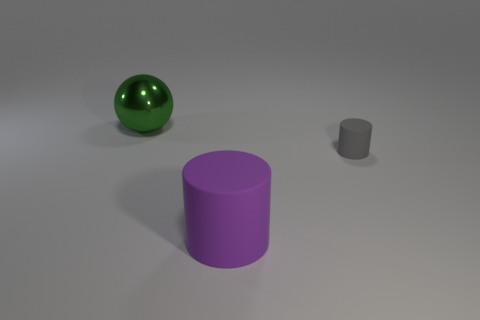Add 2 gray rubber cylinders. How many objects exist? 5 Subtract all cylinders. How many objects are left? 1 Add 1 gray cylinders. How many gray cylinders are left? 2 Add 2 matte things. How many matte things exist? 4 Subtract 0 brown cylinders. How many objects are left? 3 Subtract all small brown cylinders. Subtract all big things. How many objects are left? 1 